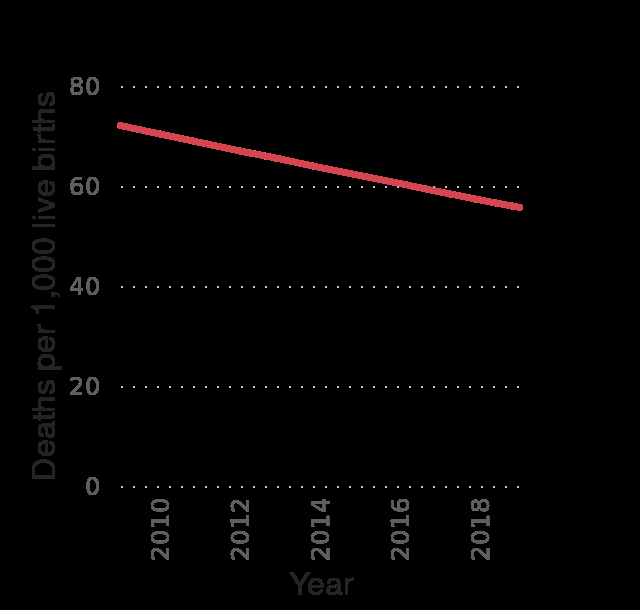<image>
How would you describe the trend in infant mortality rate in Pakistan from 2009 to 2019? The trend in infant mortality rate in Pakistan from 2009 to 2019 is consistent and steady, with a decrease from around 72 deaths per 1,000 live births to around 56 deaths per 1,000 live births. What is the title of the line graph? The title of the line graph is "Pakistan: Infant mortality rate from 2009 to 2019 (in deaths per 1,000 live births)." What is the lowest recorded infant mortality rate during the given period? The lowest recorded infant mortality rate is 0 deaths per 1,000 live births. 